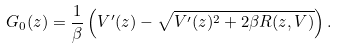<formula> <loc_0><loc_0><loc_500><loc_500>G _ { 0 } ( z ) = \frac { 1 } { \beta } \left ( V ^ { \prime } ( z ) - \sqrt { V ^ { \prime } ( z ) ^ { 2 } + 2 \beta R ( z , V ) } \right ) .</formula> 